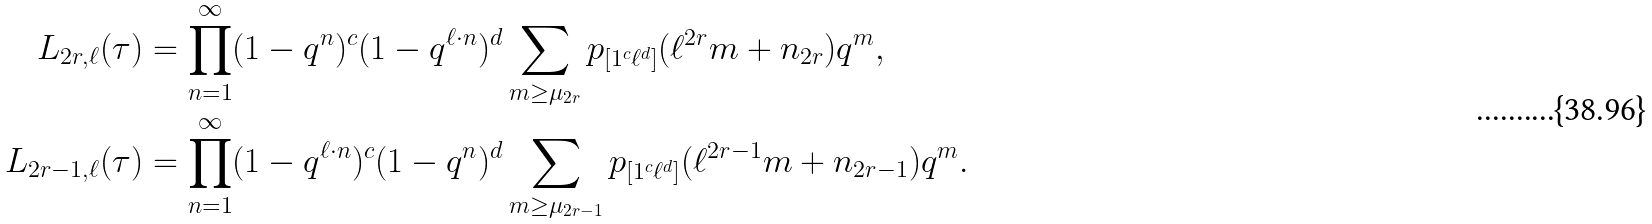Convert formula to latex. <formula><loc_0><loc_0><loc_500><loc_500>L _ { 2 r , \ell } ( \tau ) & = \prod _ { n = 1 } ^ { \infty } ( 1 - q ^ { n } ) ^ { c } ( 1 - q ^ { \ell \cdot n } ) ^ { d } \sum _ { m \geq \mu _ { 2 r } } p _ { [ 1 ^ { c } \ell ^ { d } ] } ( \ell ^ { 2 r } m + n _ { 2 r } ) q ^ { m } , \\ L _ { 2 r - 1 , \ell } ( \tau ) & = \prod _ { n = 1 } ^ { \infty } ( 1 - q ^ { \ell \cdot n } ) ^ { c } ( 1 - q ^ { n } ) ^ { d } \sum _ { m \geq \mu _ { 2 r - 1 } } p _ { [ 1 ^ { c } \ell ^ { d } ] } ( \ell ^ { 2 r - 1 } m + n _ { 2 r - 1 } ) q ^ { m } .</formula> 